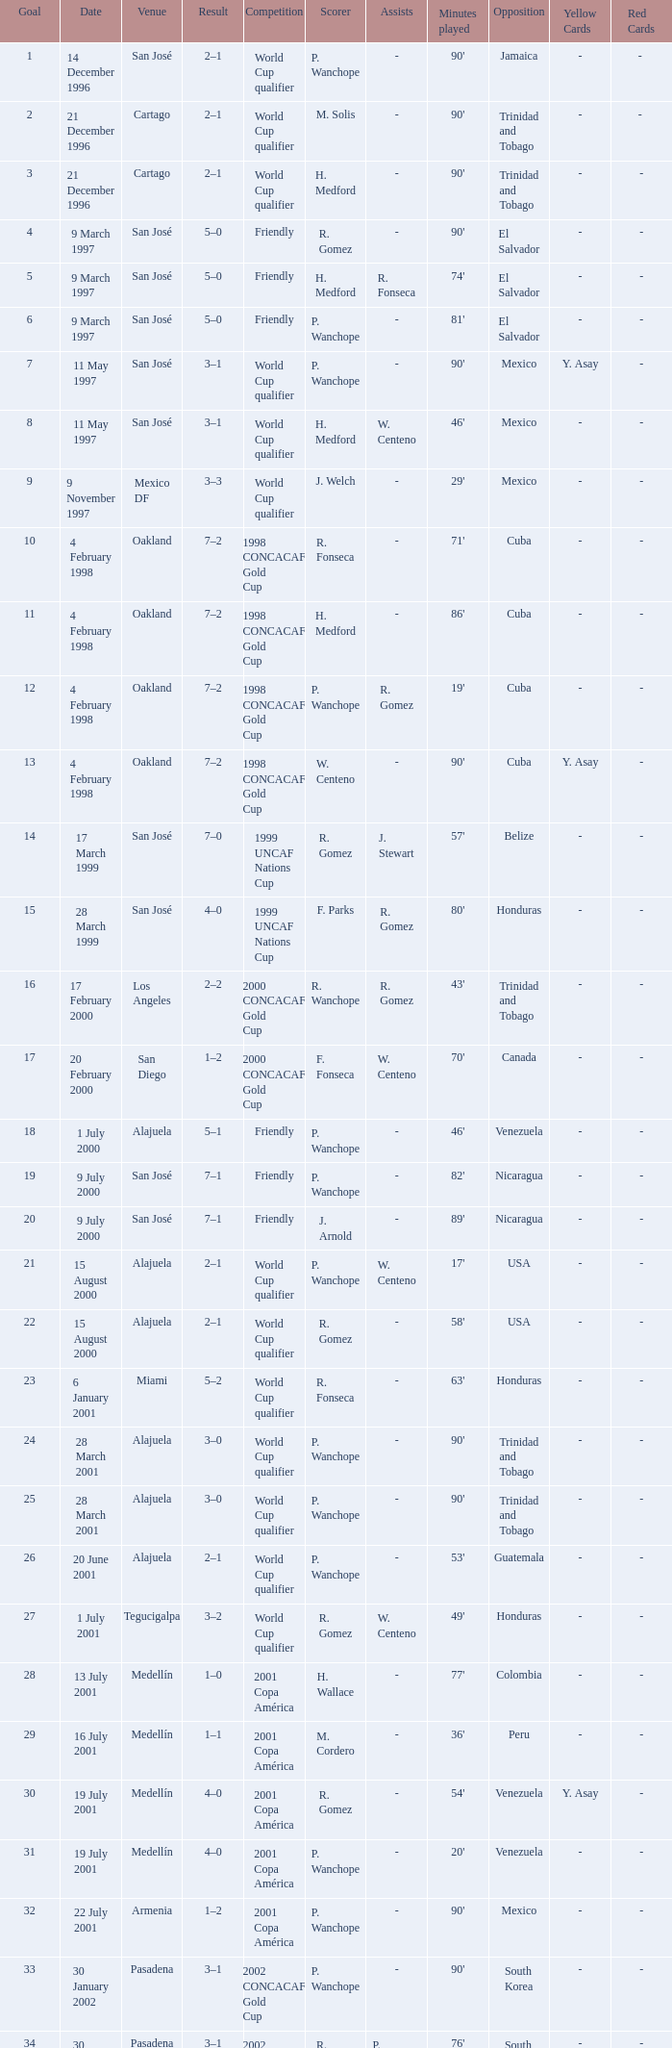What is the result in oakland? 7–2, 7–2, 7–2, 7–2. 